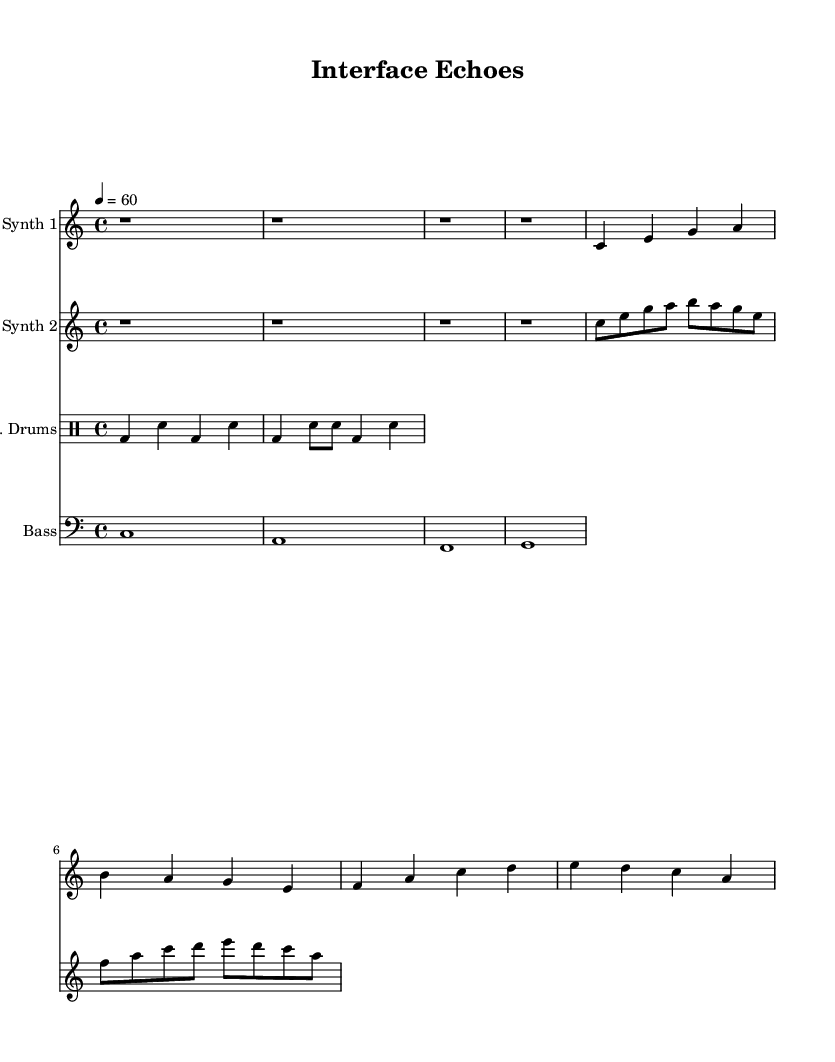What is the time signature of this music? The time signature is indicated near the beginning of the score. It shows "4/4," which means there are four beats in a measure and the quarter note receives one beat.
Answer: 4/4 What is the tempo marking for this piece? The tempo is specified in the score as "4 = 60," meaning that a quarter note should be played at a speed of 60 beats per minute.
Answer: 60 How many measures are there in Synth 1? Synth 1 consists of several measures, and by counting the bar lines, it is determined that there are four measures in total.
Answer: 4 What type of instrument is used for the electronic drums? The instrument is labeled as "E. Drums" in the score, denoting an electronic drum setup distinct from acoustic instruments.
Answer: E. Drums What is the lowest note in the bass synth part? By examining the bass synth part, the lowest note played is a low C, which is the first note of the section.
Answer: C Which instrument plays the melody primarily in this piece? Synth 1 plays the melody, as the notes listed are predominantly higher pitches that typically carry melodic content.
Answer: Synth 1 How does the pattern of the electronic drums vary throughout the piece? The electronic drum pattern consists of kick drum (bd) and snare (sn), with variations in rhythm and placement but steady in structure across the score.
Answer: Varies 